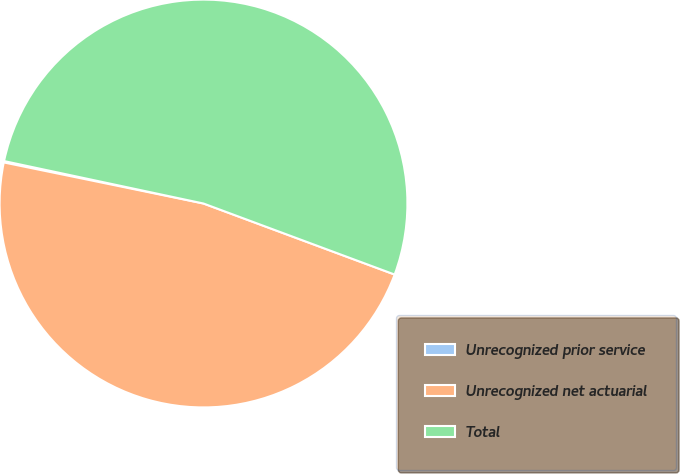Convert chart. <chart><loc_0><loc_0><loc_500><loc_500><pie_chart><fcel>Unrecognized prior service<fcel>Unrecognized net actuarial<fcel>Total<nl><fcel>0.11%<fcel>47.56%<fcel>52.32%<nl></chart> 